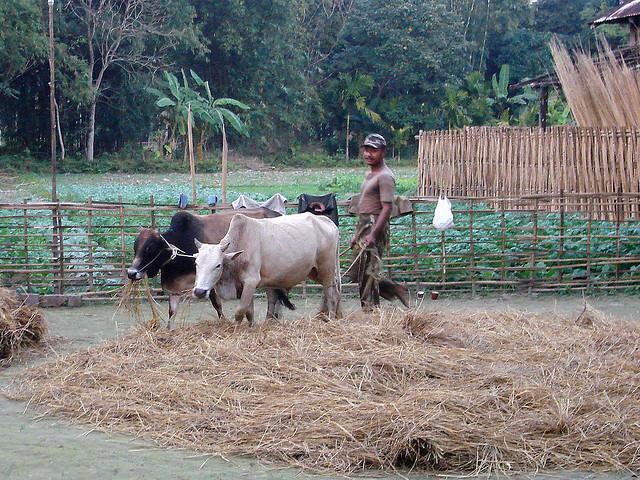How many cows are in the picture?
Give a very brief answer. 2. In how many of these screen shots is the skateboard touching the ground?
Give a very brief answer. 0. 